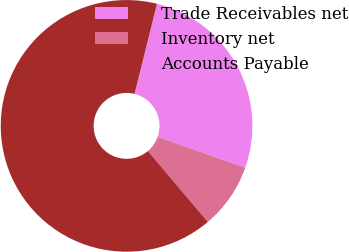<chart> <loc_0><loc_0><loc_500><loc_500><pie_chart><fcel>Trade Receivables net<fcel>Inventory net<fcel>Accounts Payable<nl><fcel>26.51%<fcel>8.43%<fcel>65.06%<nl></chart> 